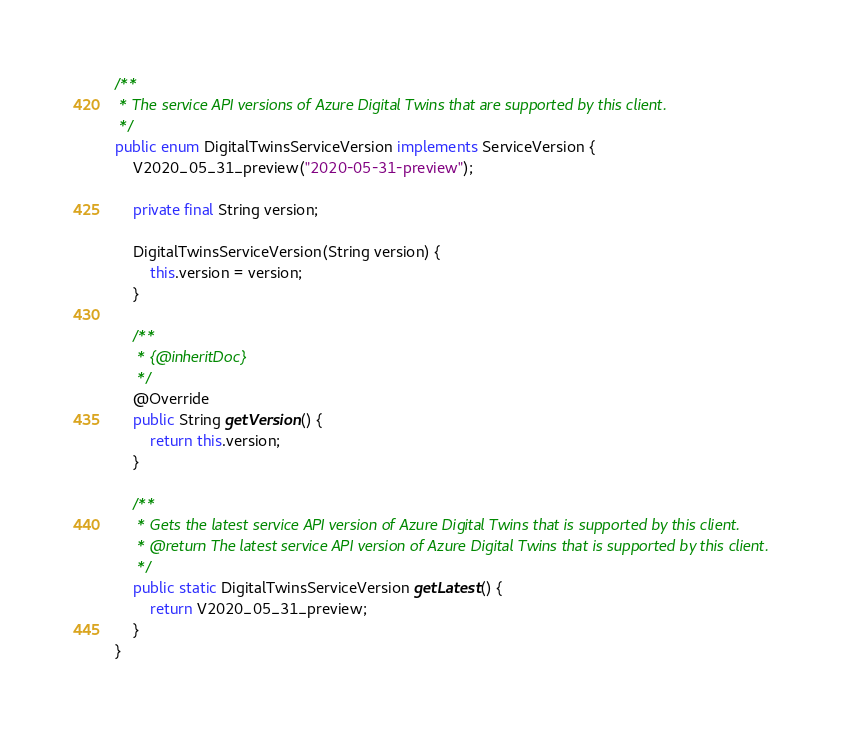<code> <loc_0><loc_0><loc_500><loc_500><_Java_>/**
 * The service API versions of Azure Digital Twins that are supported by this client.
 */
public enum DigitalTwinsServiceVersion implements ServiceVersion {
    V2020_05_31_preview("2020-05-31-preview");

    private final String version;

    DigitalTwinsServiceVersion(String version) {
        this.version = version;
    }

    /**
     * {@inheritDoc}
     */
    @Override
    public String getVersion() {
        return this.version;
    }

    /**
     * Gets the latest service API version of Azure Digital Twins that is supported by this client.
     * @return The latest service API version of Azure Digital Twins that is supported by this client.
     */
    public static DigitalTwinsServiceVersion getLatest() {
        return V2020_05_31_preview;
    }
}
</code> 